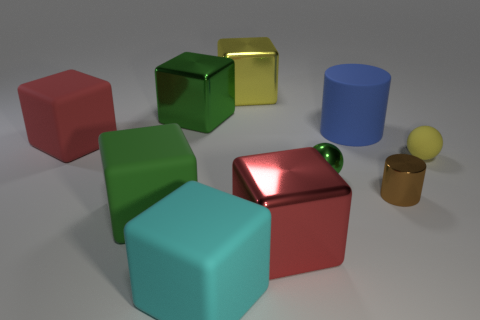Is the number of big matte cubes that are to the right of the tiny green metallic ball greater than the number of tiny brown things?
Offer a very short reply. No. What number of matte balls are the same size as the green rubber cube?
Offer a very short reply. 0. What size is the rubber block that is the same color as the metal ball?
Make the answer very short. Large. What number of big objects are either purple matte things or shiny objects?
Make the answer very short. 3. What number of small brown cylinders are there?
Provide a succinct answer. 1. Are there the same number of brown cylinders right of the small brown metal object and matte cylinders left of the green rubber block?
Your response must be concise. Yes. There is a green metallic ball; are there any small green balls behind it?
Make the answer very short. No. What is the color of the big rubber cube that is in front of the red metallic block?
Your answer should be very brief. Cyan. What is the thing behind the green metallic object on the left side of the cyan matte object made of?
Your answer should be compact. Metal. Is the number of red objects behind the tiny brown metallic cylinder less than the number of tiny metallic things left of the large red rubber cube?
Your answer should be very brief. No. 